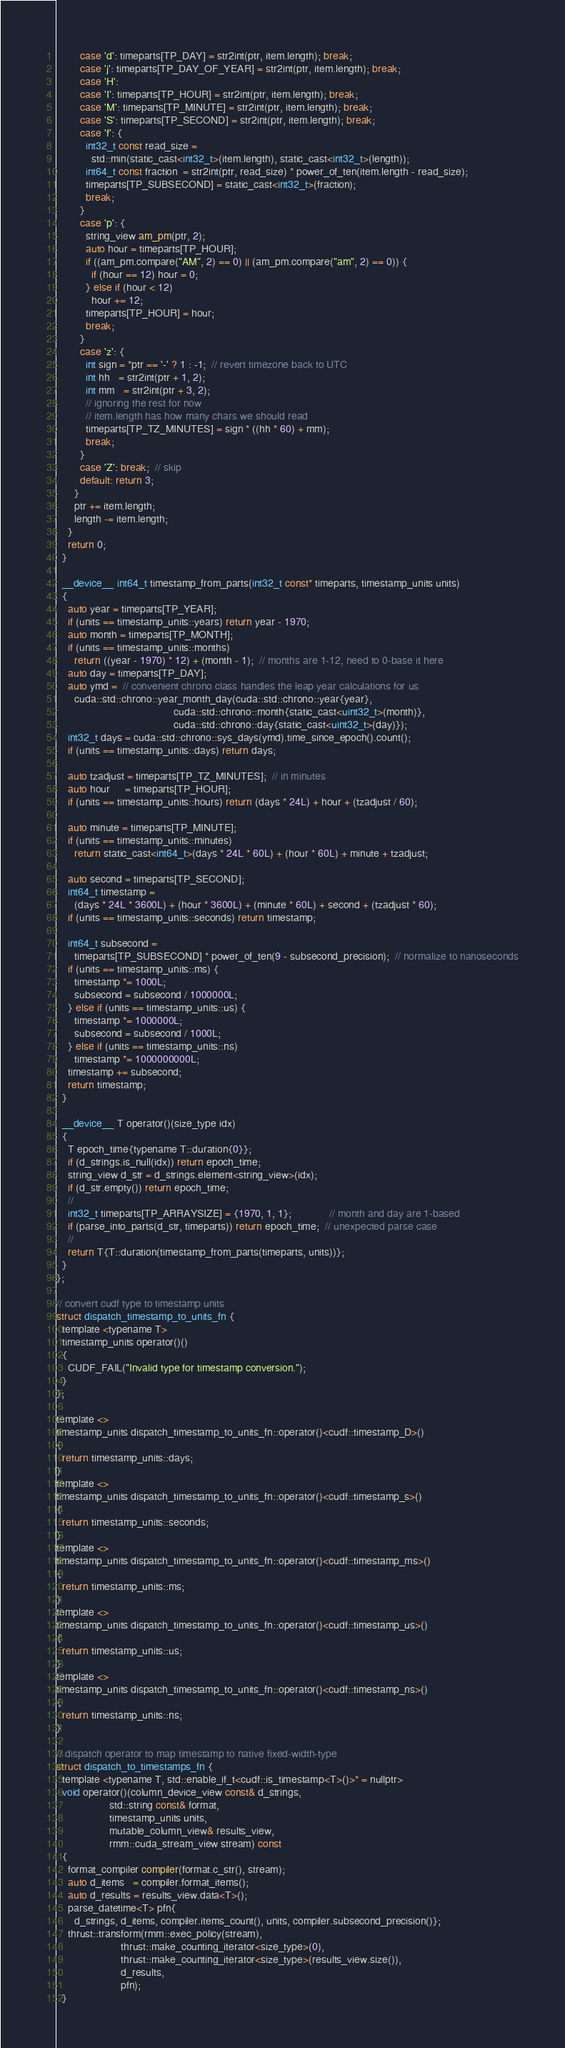<code> <loc_0><loc_0><loc_500><loc_500><_Cuda_>        case 'd': timeparts[TP_DAY] = str2int(ptr, item.length); break;
        case 'j': timeparts[TP_DAY_OF_YEAR] = str2int(ptr, item.length); break;
        case 'H':
        case 'I': timeparts[TP_HOUR] = str2int(ptr, item.length); break;
        case 'M': timeparts[TP_MINUTE] = str2int(ptr, item.length); break;
        case 'S': timeparts[TP_SECOND] = str2int(ptr, item.length); break;
        case 'f': {
          int32_t const read_size =
            std::min(static_cast<int32_t>(item.length), static_cast<int32_t>(length));
          int64_t const fraction  = str2int(ptr, read_size) * power_of_ten(item.length - read_size);
          timeparts[TP_SUBSECOND] = static_cast<int32_t>(fraction);
          break;
        }
        case 'p': {
          string_view am_pm(ptr, 2);
          auto hour = timeparts[TP_HOUR];
          if ((am_pm.compare("AM", 2) == 0) || (am_pm.compare("am", 2) == 0)) {
            if (hour == 12) hour = 0;
          } else if (hour < 12)
            hour += 12;
          timeparts[TP_HOUR] = hour;
          break;
        }
        case 'z': {
          int sign = *ptr == '-' ? 1 : -1;  // revert timezone back to UTC
          int hh   = str2int(ptr + 1, 2);
          int mm   = str2int(ptr + 3, 2);
          // ignoring the rest for now
          // item.length has how many chars we should read
          timeparts[TP_TZ_MINUTES] = sign * ((hh * 60) + mm);
          break;
        }
        case 'Z': break;  // skip
        default: return 3;
      }
      ptr += item.length;
      length -= item.length;
    }
    return 0;
  }

  __device__ int64_t timestamp_from_parts(int32_t const* timeparts, timestamp_units units)
  {
    auto year = timeparts[TP_YEAR];
    if (units == timestamp_units::years) return year - 1970;
    auto month = timeparts[TP_MONTH];
    if (units == timestamp_units::months)
      return ((year - 1970) * 12) + (month - 1);  // months are 1-12, need to 0-base it here
    auto day = timeparts[TP_DAY];
    auto ymd =  // convenient chrono class handles the leap year calculations for us
      cuda::std::chrono::year_month_day(cuda::std::chrono::year{year},
                                        cuda::std::chrono::month{static_cast<uint32_t>(month)},
                                        cuda::std::chrono::day{static_cast<uint32_t>(day)});
    int32_t days = cuda::std::chrono::sys_days(ymd).time_since_epoch().count();
    if (units == timestamp_units::days) return days;

    auto tzadjust = timeparts[TP_TZ_MINUTES];  // in minutes
    auto hour     = timeparts[TP_HOUR];
    if (units == timestamp_units::hours) return (days * 24L) + hour + (tzadjust / 60);

    auto minute = timeparts[TP_MINUTE];
    if (units == timestamp_units::minutes)
      return static_cast<int64_t>(days * 24L * 60L) + (hour * 60L) + minute + tzadjust;

    auto second = timeparts[TP_SECOND];
    int64_t timestamp =
      (days * 24L * 3600L) + (hour * 3600L) + (minute * 60L) + second + (tzadjust * 60);
    if (units == timestamp_units::seconds) return timestamp;

    int64_t subsecond =
      timeparts[TP_SUBSECOND] * power_of_ten(9 - subsecond_precision);  // normalize to nanoseconds
    if (units == timestamp_units::ms) {
      timestamp *= 1000L;
      subsecond = subsecond / 1000000L;
    } else if (units == timestamp_units::us) {
      timestamp *= 1000000L;
      subsecond = subsecond / 1000L;
    } else if (units == timestamp_units::ns)
      timestamp *= 1000000000L;
    timestamp += subsecond;
    return timestamp;
  }

  __device__ T operator()(size_type idx)
  {
    T epoch_time{typename T::duration{0}};
    if (d_strings.is_null(idx)) return epoch_time;
    string_view d_str = d_strings.element<string_view>(idx);
    if (d_str.empty()) return epoch_time;
    //
    int32_t timeparts[TP_ARRAYSIZE] = {1970, 1, 1};             // month and day are 1-based
    if (parse_into_parts(d_str, timeparts)) return epoch_time;  // unexpected parse case
    //
    return T{T::duration(timestamp_from_parts(timeparts, units))};
  }
};

// convert cudf type to timestamp units
struct dispatch_timestamp_to_units_fn {
  template <typename T>
  timestamp_units operator()()
  {
    CUDF_FAIL("Invalid type for timestamp conversion.");
  }
};

template <>
timestamp_units dispatch_timestamp_to_units_fn::operator()<cudf::timestamp_D>()
{
  return timestamp_units::days;
}
template <>
timestamp_units dispatch_timestamp_to_units_fn::operator()<cudf::timestamp_s>()
{
  return timestamp_units::seconds;
}
template <>
timestamp_units dispatch_timestamp_to_units_fn::operator()<cudf::timestamp_ms>()
{
  return timestamp_units::ms;
}
template <>
timestamp_units dispatch_timestamp_to_units_fn::operator()<cudf::timestamp_us>()
{
  return timestamp_units::us;
}
template <>
timestamp_units dispatch_timestamp_to_units_fn::operator()<cudf::timestamp_ns>()
{
  return timestamp_units::ns;
}

// dispatch operator to map timestamp to native fixed-width-type
struct dispatch_to_timestamps_fn {
  template <typename T, std::enable_if_t<cudf::is_timestamp<T>()>* = nullptr>
  void operator()(column_device_view const& d_strings,
                  std::string const& format,
                  timestamp_units units,
                  mutable_column_view& results_view,
                  rmm::cuda_stream_view stream) const
  {
    format_compiler compiler(format.c_str(), stream);
    auto d_items   = compiler.format_items();
    auto d_results = results_view.data<T>();
    parse_datetime<T> pfn{
      d_strings, d_items, compiler.items_count(), units, compiler.subsecond_precision()};
    thrust::transform(rmm::exec_policy(stream),
                      thrust::make_counting_iterator<size_type>(0),
                      thrust::make_counting_iterator<size_type>(results_view.size()),
                      d_results,
                      pfn);
  }</code> 